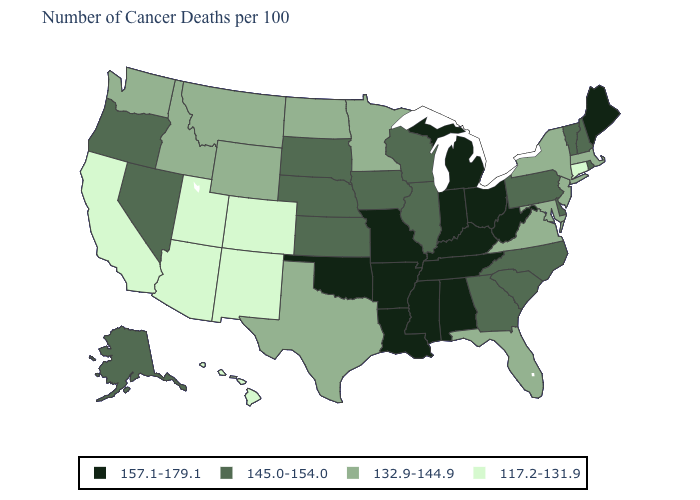Among the states that border Delaware , does New Jersey have the highest value?
Keep it brief. No. What is the value of Hawaii?
Give a very brief answer. 117.2-131.9. What is the value of Delaware?
Concise answer only. 145.0-154.0. Name the states that have a value in the range 132.9-144.9?
Keep it brief. Florida, Idaho, Maryland, Massachusetts, Minnesota, Montana, New Jersey, New York, North Dakota, Texas, Virginia, Washington, Wyoming. Does the first symbol in the legend represent the smallest category?
Concise answer only. No. What is the value of Michigan?
Give a very brief answer. 157.1-179.1. Does Tennessee have the lowest value in the South?
Be succinct. No. Does the first symbol in the legend represent the smallest category?
Short answer required. No. Which states have the lowest value in the USA?
Be succinct. Arizona, California, Colorado, Connecticut, Hawaii, New Mexico, Utah. Does Utah have the same value as California?
Short answer required. Yes. Does New Hampshire have the lowest value in the Northeast?
Give a very brief answer. No. Does Illinois have a lower value than Wyoming?
Write a very short answer. No. What is the highest value in the USA?
Answer briefly. 157.1-179.1. Which states have the lowest value in the Northeast?
Answer briefly. Connecticut. Name the states that have a value in the range 117.2-131.9?
Answer briefly. Arizona, California, Colorado, Connecticut, Hawaii, New Mexico, Utah. 